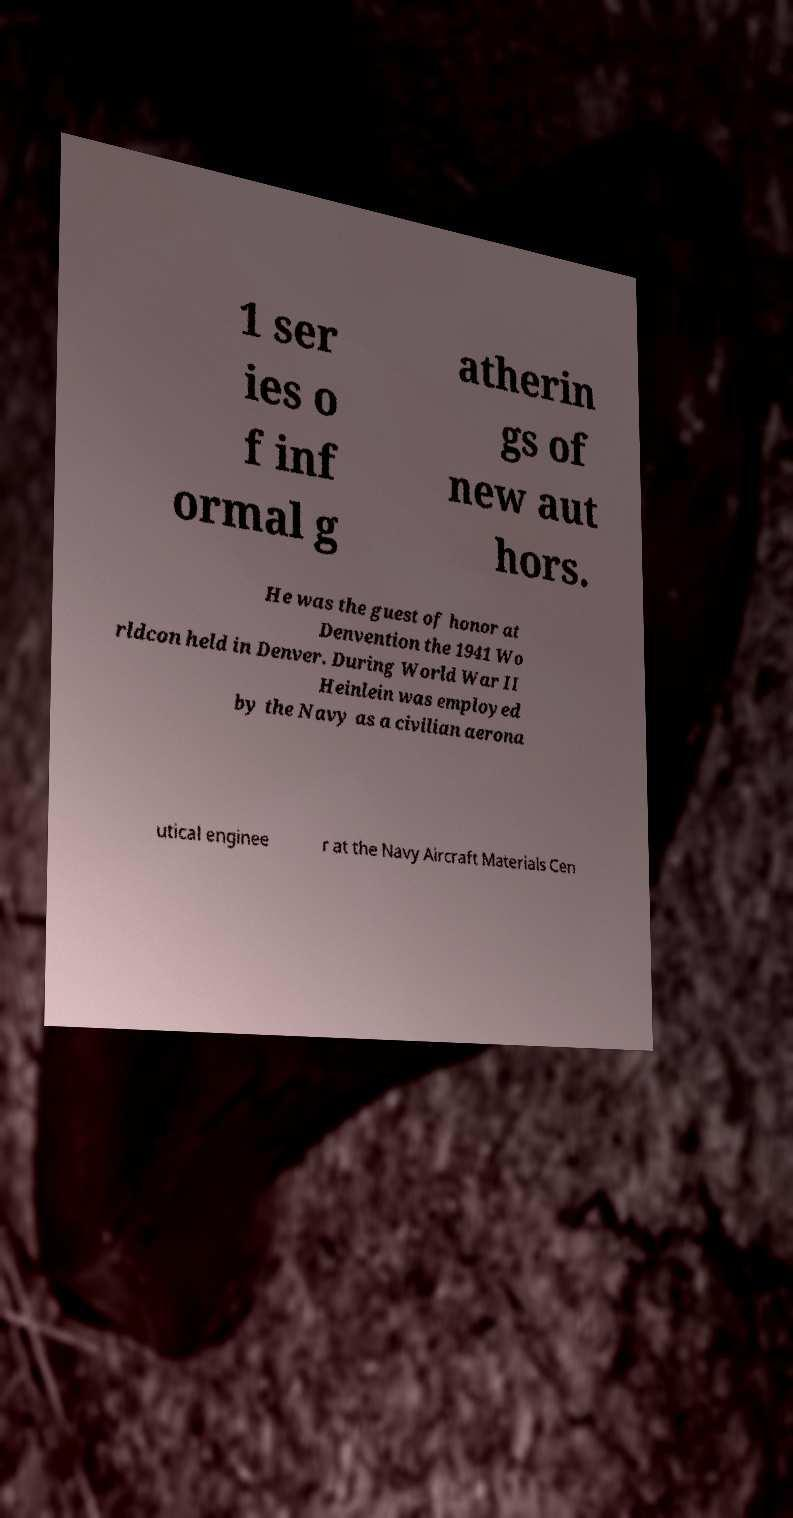There's text embedded in this image that I need extracted. Can you transcribe it verbatim? 1 ser ies o f inf ormal g atherin gs of new aut hors. He was the guest of honor at Denvention the 1941 Wo rldcon held in Denver. During World War II Heinlein was employed by the Navy as a civilian aerona utical enginee r at the Navy Aircraft Materials Cen 